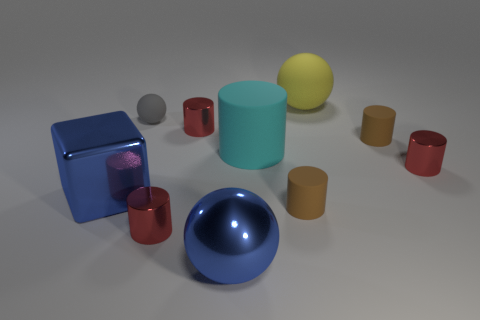How many things are blue cubes or matte objects to the right of the small ball?
Offer a very short reply. 5. There is a yellow rubber thing; does it have the same size as the blue object to the left of the large blue sphere?
Provide a succinct answer. Yes. What number of cylinders are small matte objects or tiny metallic things?
Your answer should be very brief. 5. How many large things are both right of the gray sphere and in front of the yellow thing?
Provide a succinct answer. 2. What number of other objects are there of the same color as the big cylinder?
Offer a terse response. 0. The brown object that is behind the large blue cube has what shape?
Provide a succinct answer. Cylinder. Does the tiny gray object have the same material as the large blue sphere?
Keep it short and to the point. No. What number of cyan rubber objects are to the left of the big cyan rubber thing?
Ensure brevity in your answer.  0. There is a brown thing to the left of the rubber object that is behind the gray rubber ball; what is its shape?
Ensure brevity in your answer.  Cylinder. Is there any other thing that has the same shape as the tiny gray rubber object?
Provide a succinct answer. Yes. 